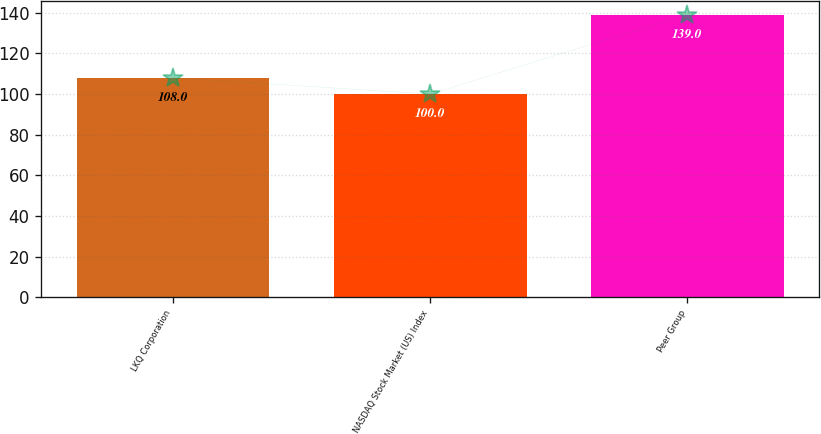<chart> <loc_0><loc_0><loc_500><loc_500><bar_chart><fcel>LKQ Corporation<fcel>NASDAQ Stock Market (US) Index<fcel>Peer Group<nl><fcel>108<fcel>100<fcel>139<nl></chart> 